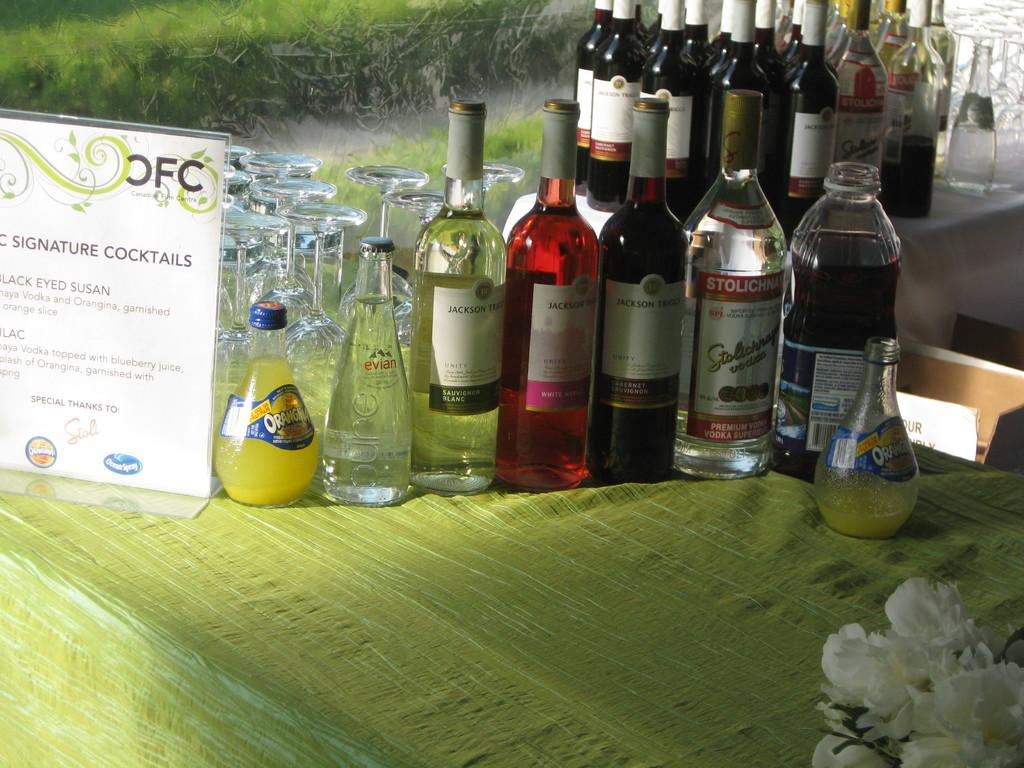What type of bottles are in the image? There is a group of wine bottles in the image. What else can be seen in the image besides the wine bottles? There are glasses in the image. Where are the wine bottles and glasses located? The wine bottles and glasses are on a table. Can you tell me how many snakes are slithering around the wine bottles in the image? There are no snakes present in the image; it features a group of wine bottles and glasses on a table. What type of animal can be seen in the zoo in the image? There is no zoo or animal present in the image. 